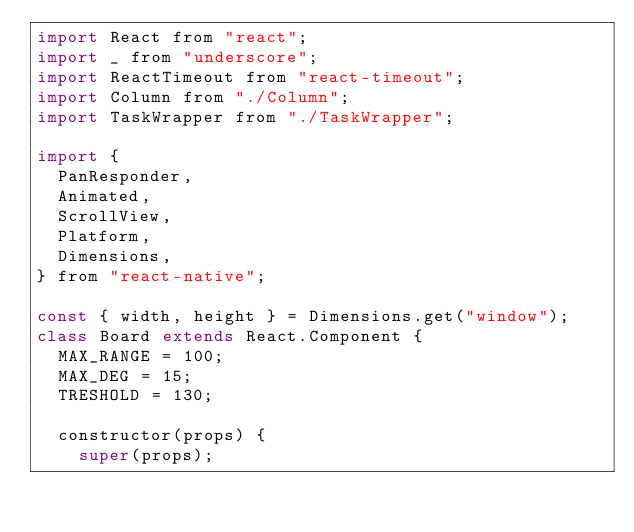Convert code to text. <code><loc_0><loc_0><loc_500><loc_500><_JavaScript_>import React from "react";
import _ from "underscore";
import ReactTimeout from "react-timeout";
import Column from "./Column";
import TaskWrapper from "./TaskWrapper";

import {
	PanResponder,
	Animated,
	ScrollView,
	Platform,
	Dimensions,
} from "react-native";

const { width, height } = Dimensions.get("window");
class Board extends React.Component {
	MAX_RANGE = 100;
	MAX_DEG = 15;
	TRESHOLD = 130;

	constructor(props) {
		super(props);
</code> 